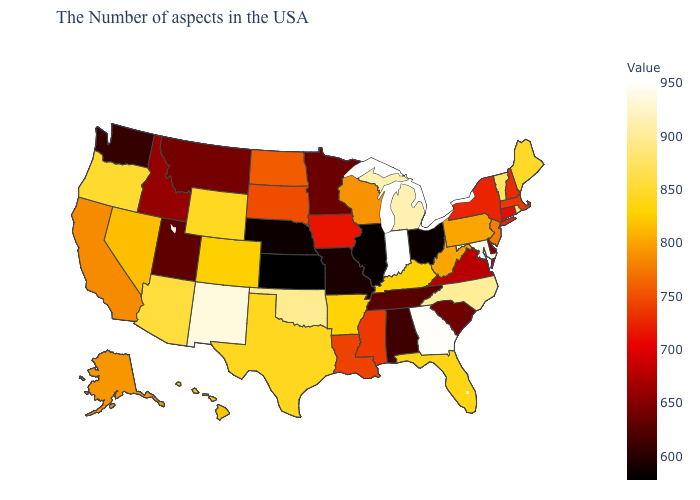Does Delaware have a lower value than Colorado?
Short answer required. Yes. Does Indiana have the highest value in the MidWest?
Answer briefly. Yes. Does Minnesota have a lower value than Arkansas?
Write a very short answer. Yes. Which states have the lowest value in the South?
Answer briefly. Alabama. Which states hav the highest value in the MidWest?
Be succinct. Indiana. Among the states that border Washington , does Idaho have the highest value?
Answer briefly. No. Among the states that border New Hampshire , which have the lowest value?
Be succinct. Massachusetts. Does Indiana have the highest value in the MidWest?
Keep it brief. Yes. 